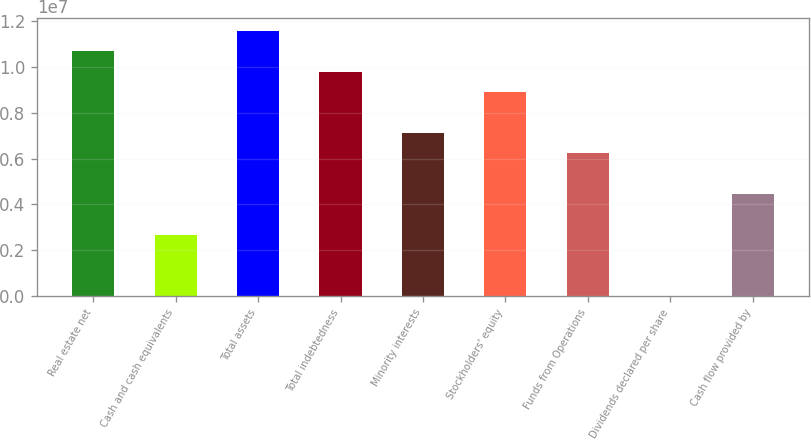<chart> <loc_0><loc_0><loc_500><loc_500><bar_chart><fcel>Real estate net<fcel>Cash and cash equivalents<fcel>Total assets<fcel>Total indebtedness<fcel>Minority interests<fcel>Stockholders' equity<fcel>Funds from Operations<fcel>Dividends declared per share<fcel>Cash flow provided by<nl><fcel>1.06828e+07<fcel>2.67071e+06<fcel>1.15731e+07<fcel>9.7926e+06<fcel>7.1219e+06<fcel>8.90237e+06<fcel>6.23166e+06<fcel>5.19<fcel>4.45119e+06<nl></chart> 